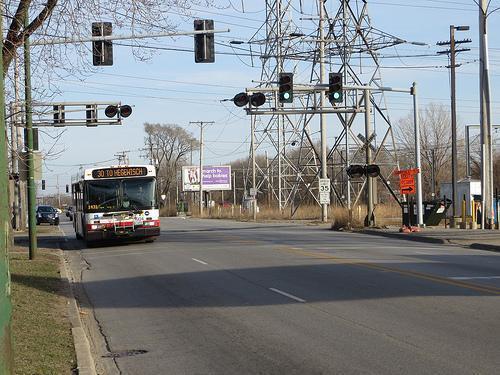How many buses are in the picture?
Give a very brief answer. 1. How many green lights are in the picture?
Give a very brief answer. 2. 